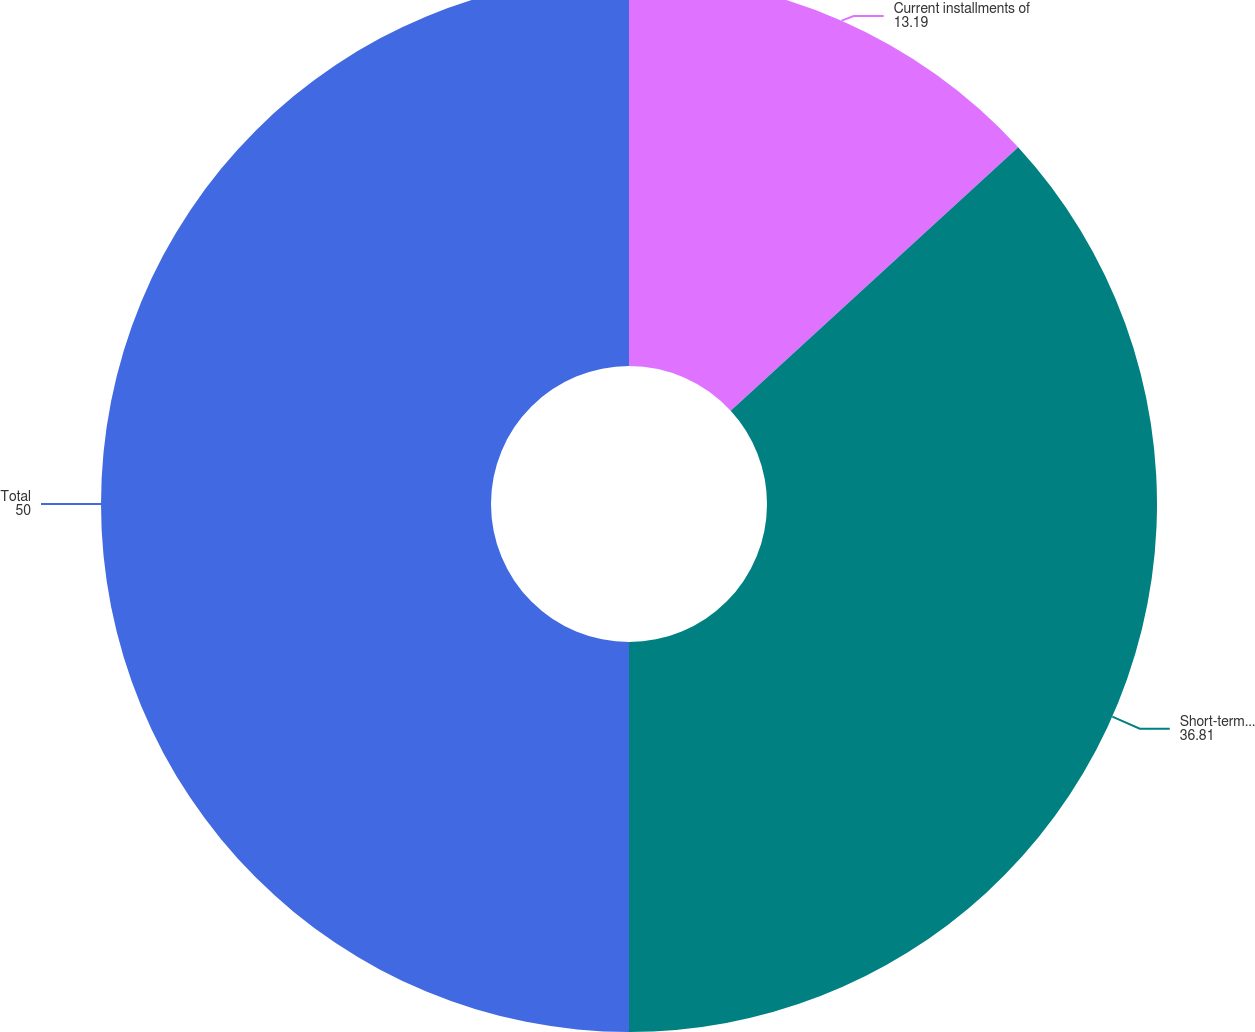Convert chart to OTSL. <chart><loc_0><loc_0><loc_500><loc_500><pie_chart><fcel>Current installments of<fcel>Short-term borrowings<fcel>Total<nl><fcel>13.19%<fcel>36.81%<fcel>50.0%<nl></chart> 